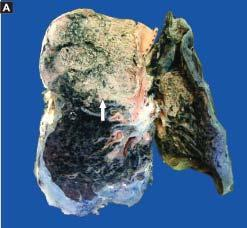what does the sectioned surface of the lung show?
Answer the question using a single word or phrase. Grey-brown 